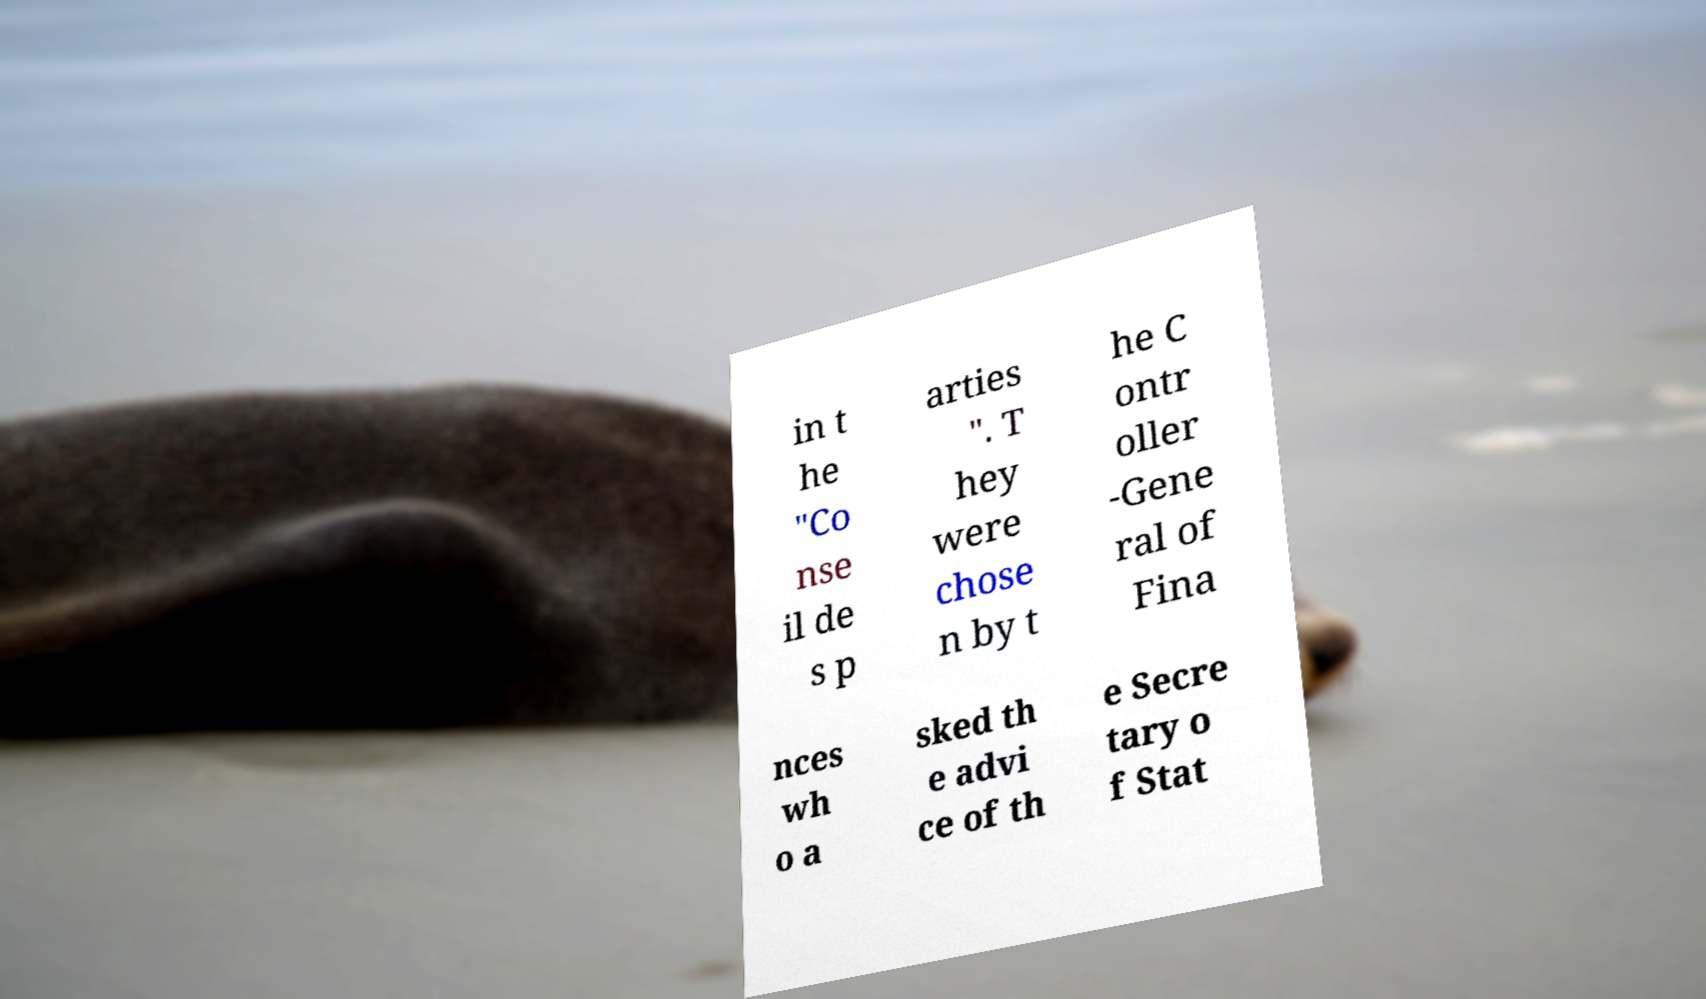I need the written content from this picture converted into text. Can you do that? in t he "Co nse il de s p arties ". T hey were chose n by t he C ontr oller -Gene ral of Fina nces wh o a sked th e advi ce of th e Secre tary o f Stat 